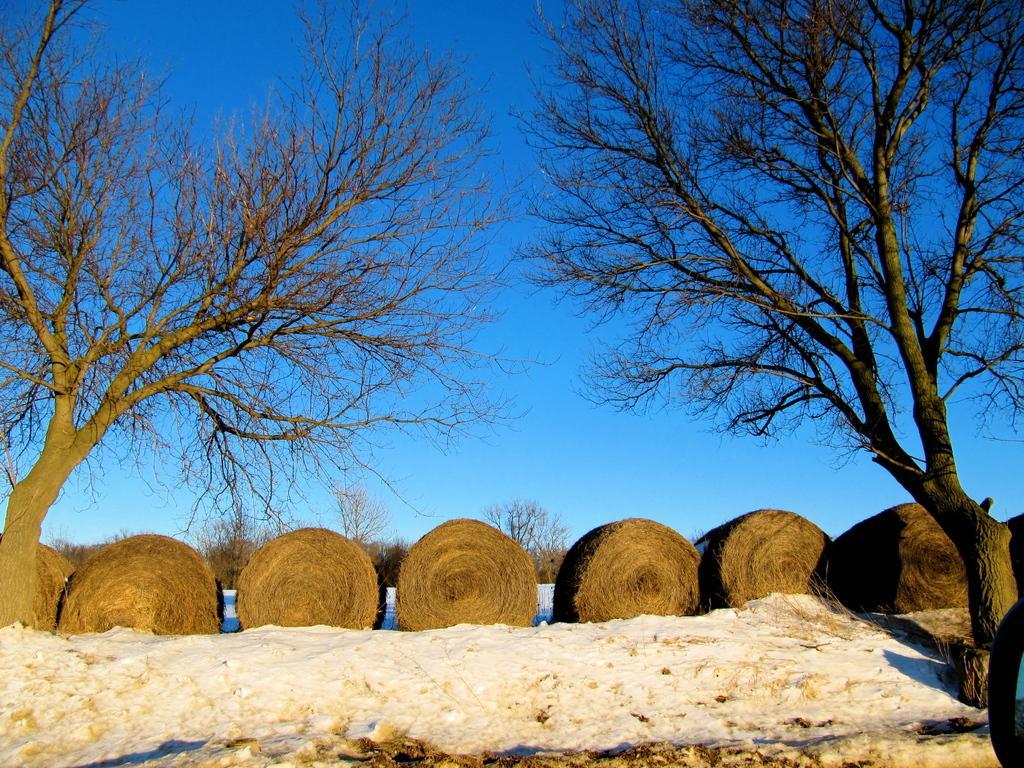How would you summarize this image in a sentence or two? In this image we can see a group of dried grass placed on the ground in the form of rolls. We can also see some snow, trees and the sky which looks cloudy. 